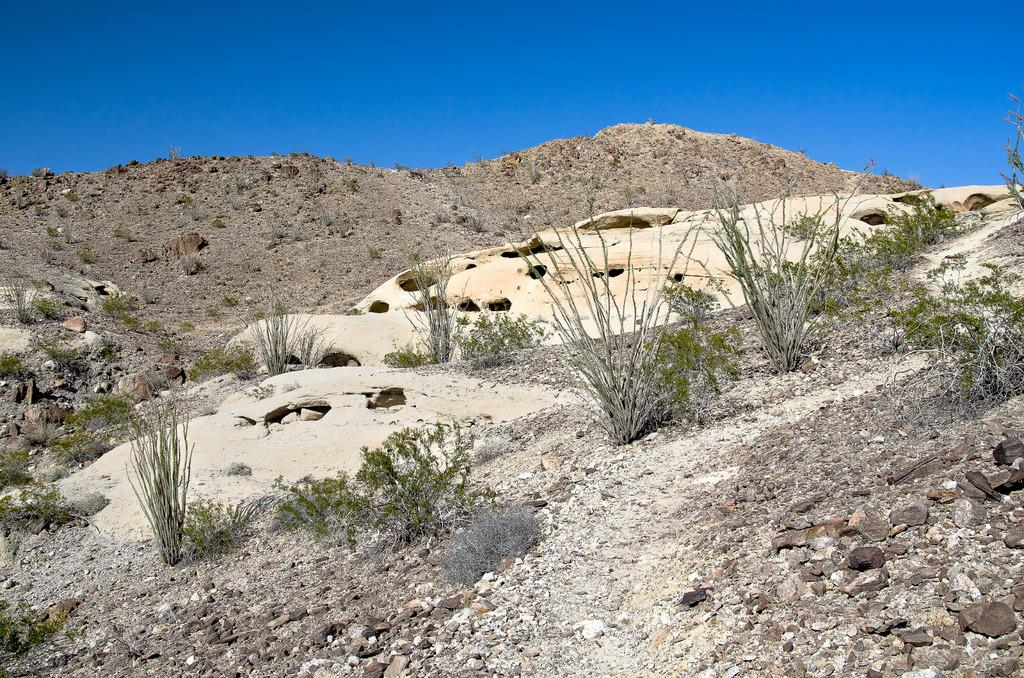What type of natural formation can be seen at the bottom of the image? There are mountains at the bottom of the image. What other elements are present at the bottom of the image? Plants, small stones, and grass are visible at the bottom of the image. What is visible at the top of the image? There is sky visible at the top of the image. What type of poison is being used by the servant in the image? There is no band, servant, or poison present in the image. 